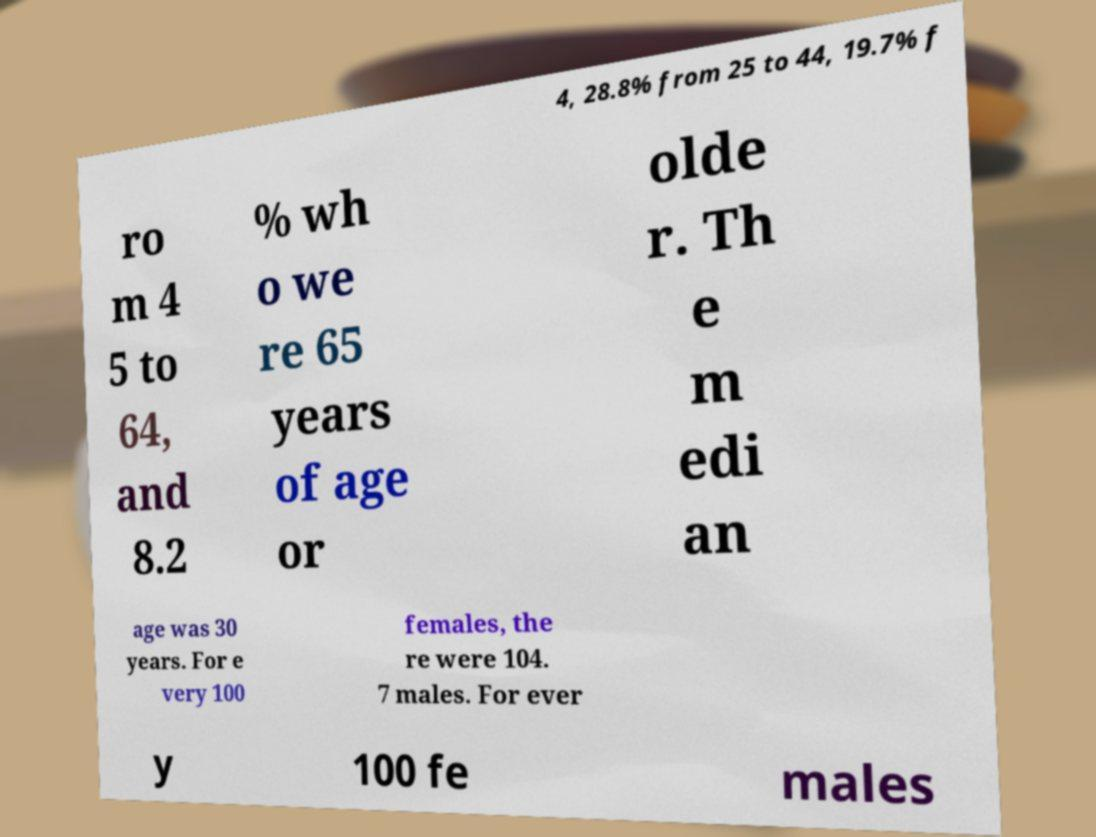I need the written content from this picture converted into text. Can you do that? 4, 28.8% from 25 to 44, 19.7% f ro m 4 5 to 64, and 8.2 % wh o we re 65 years of age or olde r. Th e m edi an age was 30 years. For e very 100 females, the re were 104. 7 males. For ever y 100 fe males 